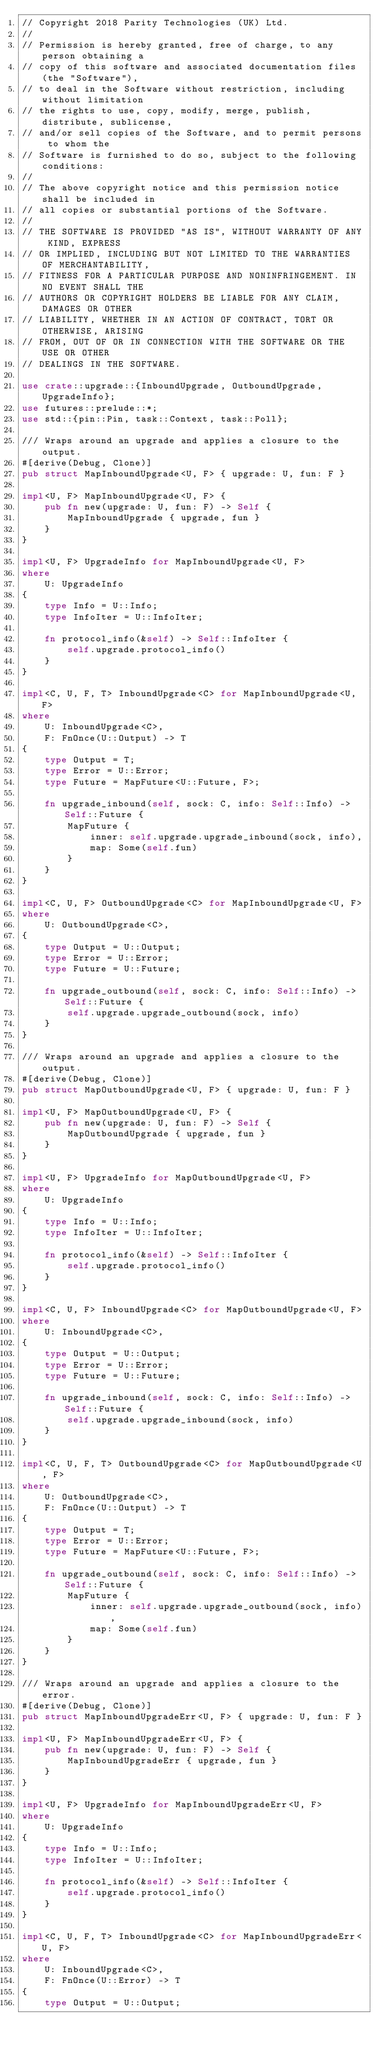<code> <loc_0><loc_0><loc_500><loc_500><_Rust_>// Copyright 2018 Parity Technologies (UK) Ltd.
//
// Permission is hereby granted, free of charge, to any person obtaining a
// copy of this software and associated documentation files (the "Software"),
// to deal in the Software without restriction, including without limitation
// the rights to use, copy, modify, merge, publish, distribute, sublicense,
// and/or sell copies of the Software, and to permit persons to whom the
// Software is furnished to do so, subject to the following conditions:
//
// The above copyright notice and this permission notice shall be included in
// all copies or substantial portions of the Software.
//
// THE SOFTWARE IS PROVIDED "AS IS", WITHOUT WARRANTY OF ANY KIND, EXPRESS
// OR IMPLIED, INCLUDING BUT NOT LIMITED TO THE WARRANTIES OF MERCHANTABILITY,
// FITNESS FOR A PARTICULAR PURPOSE AND NONINFRINGEMENT. IN NO EVENT SHALL THE
// AUTHORS OR COPYRIGHT HOLDERS BE LIABLE FOR ANY CLAIM, DAMAGES OR OTHER
// LIABILITY, WHETHER IN AN ACTION OF CONTRACT, TORT OR OTHERWISE, ARISING
// FROM, OUT OF OR IN CONNECTION WITH THE SOFTWARE OR THE USE OR OTHER
// DEALINGS IN THE SOFTWARE.

use crate::upgrade::{InboundUpgrade, OutboundUpgrade, UpgradeInfo};
use futures::prelude::*;
use std::{pin::Pin, task::Context, task::Poll};

/// Wraps around an upgrade and applies a closure to the output.
#[derive(Debug, Clone)]
pub struct MapInboundUpgrade<U, F> { upgrade: U, fun: F }

impl<U, F> MapInboundUpgrade<U, F> {
    pub fn new(upgrade: U, fun: F) -> Self {
        MapInboundUpgrade { upgrade, fun }
    }
}

impl<U, F> UpgradeInfo for MapInboundUpgrade<U, F>
where
    U: UpgradeInfo
{
    type Info = U::Info;
    type InfoIter = U::InfoIter;

    fn protocol_info(&self) -> Self::InfoIter {
        self.upgrade.protocol_info()
    }
}

impl<C, U, F, T> InboundUpgrade<C> for MapInboundUpgrade<U, F>
where
    U: InboundUpgrade<C>,
    F: FnOnce(U::Output) -> T
{
    type Output = T;
    type Error = U::Error;
    type Future = MapFuture<U::Future, F>;

    fn upgrade_inbound(self, sock: C, info: Self::Info) -> Self::Future {
        MapFuture {
            inner: self.upgrade.upgrade_inbound(sock, info),
            map: Some(self.fun)
        }
    }
}

impl<C, U, F> OutboundUpgrade<C> for MapInboundUpgrade<U, F>
where
    U: OutboundUpgrade<C>,
{
    type Output = U::Output;
    type Error = U::Error;
    type Future = U::Future;

    fn upgrade_outbound(self, sock: C, info: Self::Info) -> Self::Future {
        self.upgrade.upgrade_outbound(sock, info)
    }
}

/// Wraps around an upgrade and applies a closure to the output.
#[derive(Debug, Clone)]
pub struct MapOutboundUpgrade<U, F> { upgrade: U, fun: F }

impl<U, F> MapOutboundUpgrade<U, F> {
    pub fn new(upgrade: U, fun: F) -> Self {
        MapOutboundUpgrade { upgrade, fun }
    }
}

impl<U, F> UpgradeInfo for MapOutboundUpgrade<U, F>
where
    U: UpgradeInfo
{
    type Info = U::Info;
    type InfoIter = U::InfoIter;

    fn protocol_info(&self) -> Self::InfoIter {
        self.upgrade.protocol_info()
    }
}

impl<C, U, F> InboundUpgrade<C> for MapOutboundUpgrade<U, F>
where
    U: InboundUpgrade<C>,
{
    type Output = U::Output;
    type Error = U::Error;
    type Future = U::Future;

    fn upgrade_inbound(self, sock: C, info: Self::Info) -> Self::Future {
        self.upgrade.upgrade_inbound(sock, info)
    }
}

impl<C, U, F, T> OutboundUpgrade<C> for MapOutboundUpgrade<U, F>
where
    U: OutboundUpgrade<C>,
    F: FnOnce(U::Output) -> T
{
    type Output = T;
    type Error = U::Error;
    type Future = MapFuture<U::Future, F>;

    fn upgrade_outbound(self, sock: C, info: Self::Info) -> Self::Future {
        MapFuture {
            inner: self.upgrade.upgrade_outbound(sock, info),
            map: Some(self.fun)
        }
    }
}

/// Wraps around an upgrade and applies a closure to the error.
#[derive(Debug, Clone)]
pub struct MapInboundUpgradeErr<U, F> { upgrade: U, fun: F }

impl<U, F> MapInboundUpgradeErr<U, F> {
    pub fn new(upgrade: U, fun: F) -> Self {
        MapInboundUpgradeErr { upgrade, fun }
    }
}

impl<U, F> UpgradeInfo for MapInboundUpgradeErr<U, F>
where
    U: UpgradeInfo
{
    type Info = U::Info;
    type InfoIter = U::InfoIter;

    fn protocol_info(&self) -> Self::InfoIter {
        self.upgrade.protocol_info()
    }
}

impl<C, U, F, T> InboundUpgrade<C> for MapInboundUpgradeErr<U, F>
where
    U: InboundUpgrade<C>,
    F: FnOnce(U::Error) -> T
{
    type Output = U::Output;</code> 